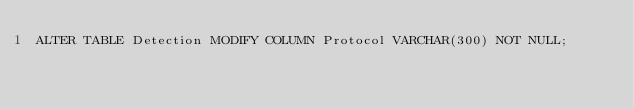<code> <loc_0><loc_0><loc_500><loc_500><_SQL_>ALTER TABLE Detection MODIFY COLUMN Protocol VARCHAR(300) NOT NULL;</code> 